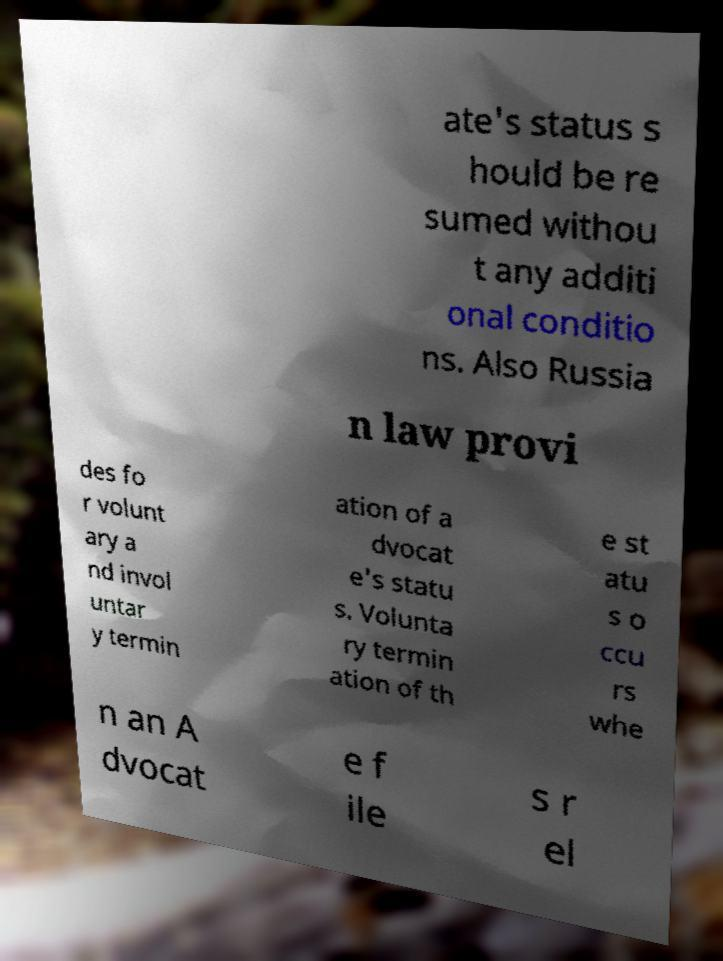For documentation purposes, I need the text within this image transcribed. Could you provide that? ate's status s hould be re sumed withou t any additi onal conditio ns. Also Russia n law provi des fo r volunt ary a nd invol untar y termin ation of a dvocat e's statu s. Volunta ry termin ation of th e st atu s o ccu rs whe n an A dvocat e f ile s r el 